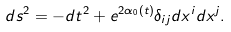Convert formula to latex. <formula><loc_0><loc_0><loc_500><loc_500>d s ^ { 2 } = - d t ^ { 2 } + e ^ { 2 \alpha _ { 0 } ( t ) } \delta _ { i j } d x ^ { i } d x ^ { j } .</formula> 